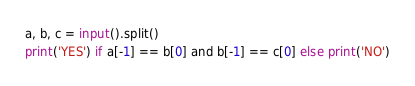<code> <loc_0><loc_0><loc_500><loc_500><_Python_>a, b, c = input().split()
print('YES') if a[-1] == b[0] and b[-1] == c[0] else print('NO')</code> 